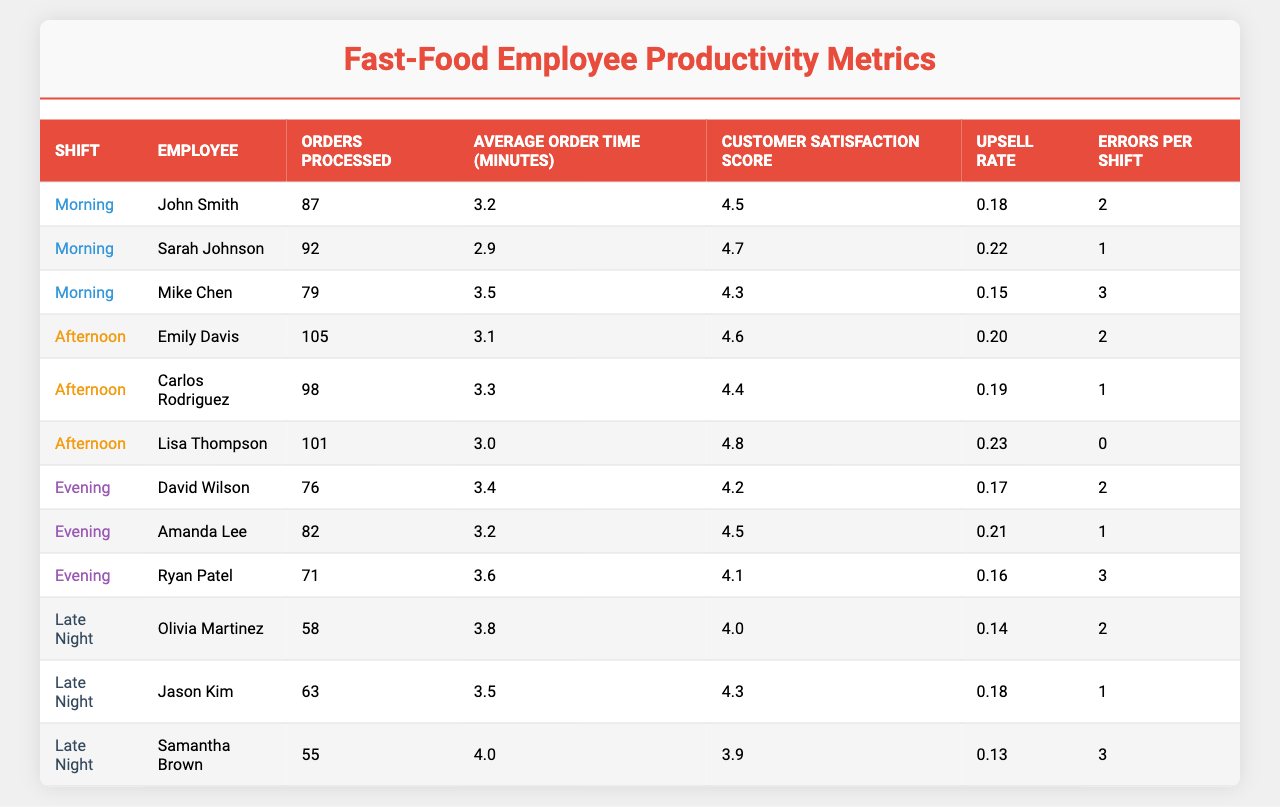What is the highest number of orders processed in a single shift? In the table, the highest value in the "Orders Processed" column is 105, which corresponds to Emily Davis in the Afternoon shift.
Answer: 105 Who had the lowest customer satisfaction score? The lowest score in the "Customer Satisfaction Score" column is 3.9, which corresponds to Samantha Brown in the Late Night shift.
Answer: 3.9 How many shifts did Sarah Johnson work? The table shows data for Sarah Johnson only under the Morning shift, indicating she worked one shift.
Answer: 1 What is the average order time across all employees? The average order time is calculated by summing all order times (3.2 + 2.9 + 3.5 + 3.1 + 3.3 + 3.0 + 3.4 + 3.2 + 3.6 + 3.8 + 3.5 + 4.0) = 39.9 minutes, divided by the 12 employees, resulting in an average of approximately 3.33 minutes.
Answer: 3.33 Which shift had the highest average upsell rate? The average upsell rate for each shift is as follows: Morning (0.18+0.22+0.15)/3 = 0.18, Afternoon (0.20+0.19+0.23)/3 = 0.21, Evening (0.17+0.21+0.16)/3 = 0.18, Late Night (0.14+0.18+0.13)/3 = 0.15. Afternoon has the highest average upsell rate at 0.21.
Answer: Afternoon Is there an employee who processed more than 100 orders with a customer satisfaction score above 4.5? Yes, Lisa Thompson processed 101 orders with a customer satisfaction score of 4.8, meeting both conditions.
Answer: Yes What is the difference in average order time between the Morning and Late Night shifts? The average order time for the Morning shift is (3.2+2.9+3.5)/3 = 3.2 minutes, and for Late Night it is (3.8+3.5+4.0)/3 = 3.77 minutes. The difference is 3.77 - 3.2 = 0.57 minutes.
Answer: 0.57 Who made fewer errors during their shift, and what was the error count? The employee with the fewest errors is Lisa Thompson, who made 0 errors during her shift.
Answer: Lisa Thompson, 0 errors What is the average number of orders processed per shift for the Evening shift? For the Evening shift, the total orders processed are (76 + 82 + 71) = 229, divided by 3 employees gives an average of 229 / 3 = approximately 76.33 orders.
Answer: 76.33 What is the total number of errors made by employees during the Late Night shift? The Late Night shift had errors counted as follows: Olivia Martinez (2), Jason Kim (1), and Samantha Brown (3), totaling 2 + 1 + 3 = 6 errors made during that shift.
Answer: 6 